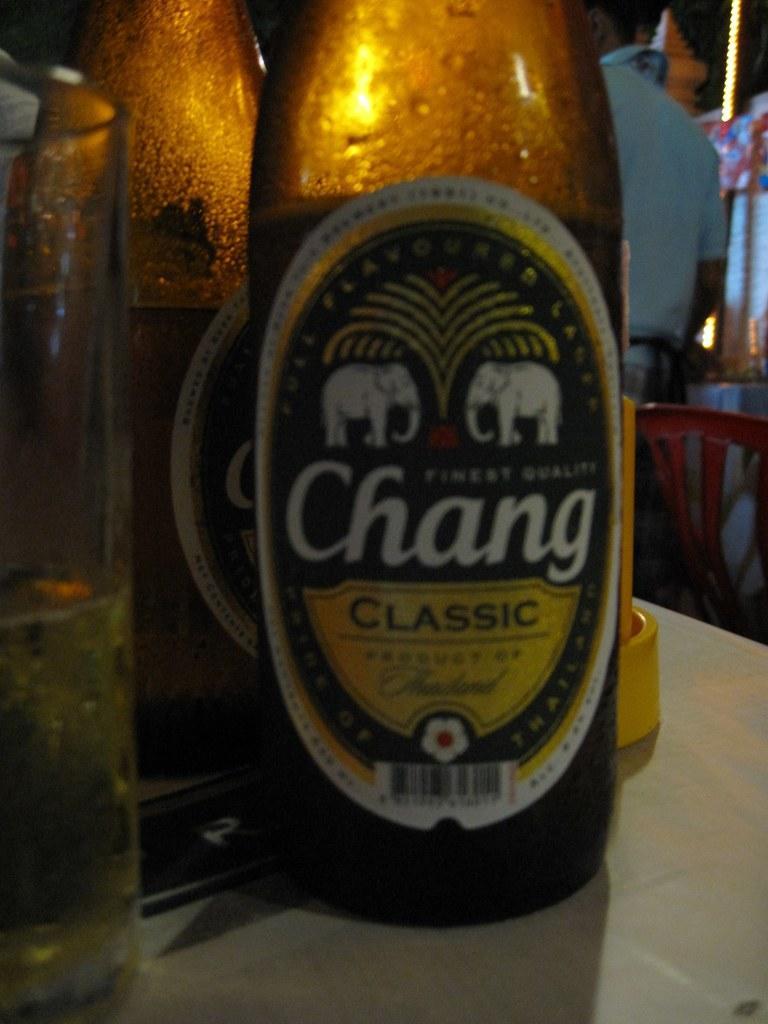How would you summarize this image in a sentence or two? In this image I can see wine bottles and glass of wine on the table. In the background there is a chair and there are some other objects. 